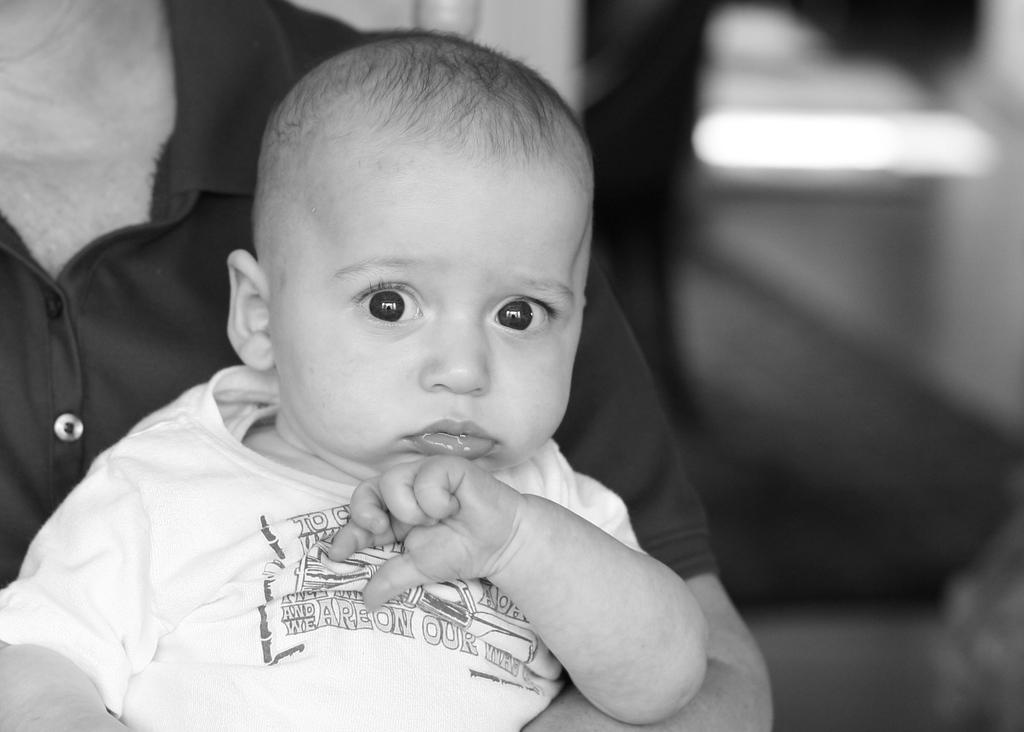What is happening in the image? There is a person holding a baby in the image. What is the color scheme of the image? The image is black and white in color. What type of soap is the baby using in the image? There is no soap present in the image; it is a black and white image of a person holding a baby. Can you see any bears or wings in the image? No, there are no bears or wings visible in the image. 